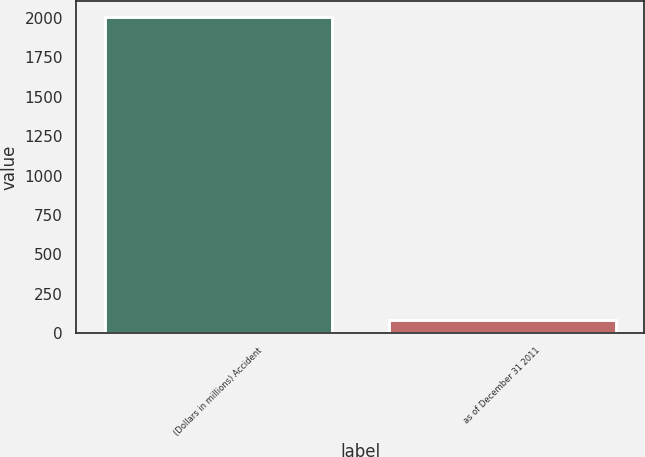<chart> <loc_0><loc_0><loc_500><loc_500><bar_chart><fcel>(Dollars in millions) Accident<fcel>as of December 31 2011<nl><fcel>2009<fcel>83<nl></chart> 